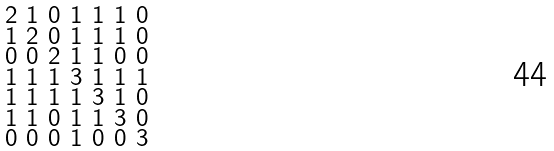Convert formula to latex. <formula><loc_0><loc_0><loc_500><loc_500>\begin{smallmatrix} 2 & 1 & 0 & 1 & 1 & 1 & 0 \\ 1 & 2 & 0 & 1 & 1 & 1 & 0 \\ 0 & 0 & 2 & 1 & 1 & 0 & 0 \\ 1 & 1 & 1 & 3 & 1 & 1 & 1 \\ 1 & 1 & 1 & 1 & 3 & 1 & 0 \\ 1 & 1 & 0 & 1 & 1 & 3 & 0 \\ 0 & 0 & 0 & 1 & 0 & 0 & 3 \end{smallmatrix}</formula> 